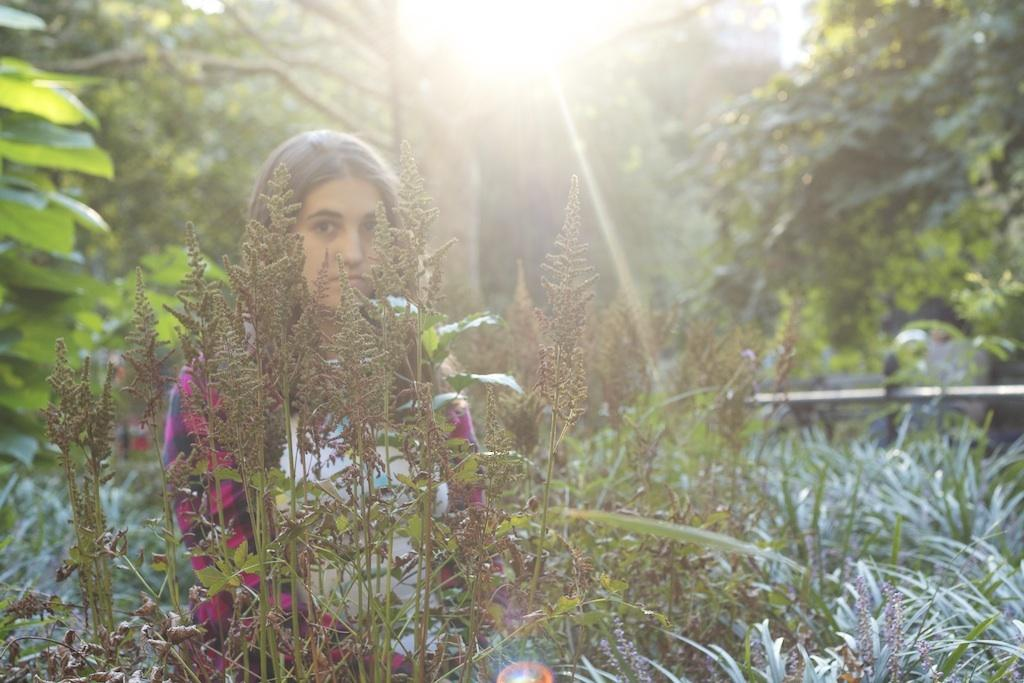Who is the main subject in the image? There is a lady standing in the center of the image. What can be seen at the bottom of the image? There are plants and grass at the bottom of the image. What type of vegetation is visible in the background of the image? There are trees in the background of the image. What type of glue is being used to sort the plane in the image? There is no glue, sorting, or plane present in the image. 